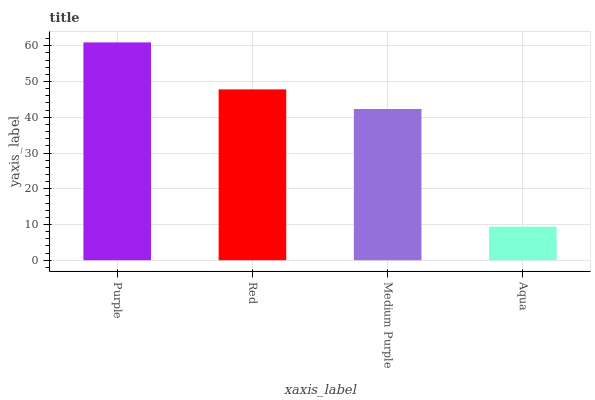Is Aqua the minimum?
Answer yes or no. Yes. Is Purple the maximum?
Answer yes or no. Yes. Is Red the minimum?
Answer yes or no. No. Is Red the maximum?
Answer yes or no. No. Is Purple greater than Red?
Answer yes or no. Yes. Is Red less than Purple?
Answer yes or no. Yes. Is Red greater than Purple?
Answer yes or no. No. Is Purple less than Red?
Answer yes or no. No. Is Red the high median?
Answer yes or no. Yes. Is Medium Purple the low median?
Answer yes or no. Yes. Is Purple the high median?
Answer yes or no. No. Is Purple the low median?
Answer yes or no. No. 